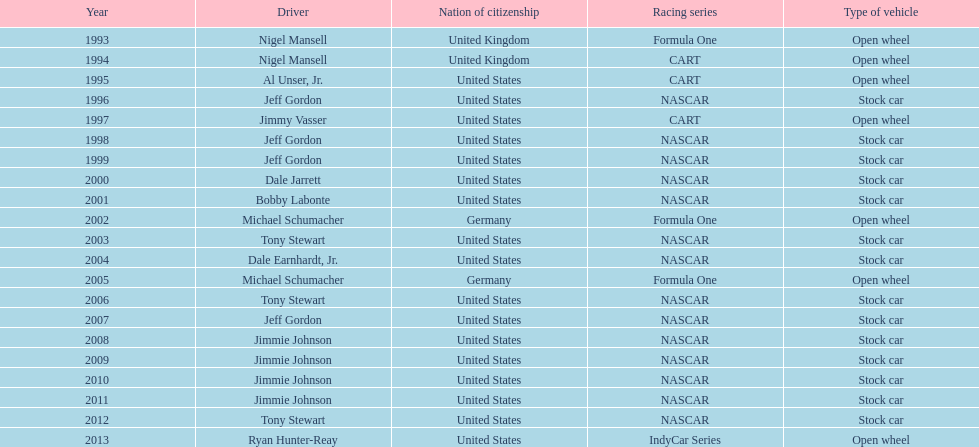In the group of nigel mansell, al unser jr., michael schumacher, and jeff gordon, only one of them has won only one espy award. who is that driver? Al Unser, Jr. Could you parse the entire table as a dict? {'header': ['Year', 'Driver', 'Nation of citizenship', 'Racing series', 'Type of vehicle'], 'rows': [['1993', 'Nigel Mansell', 'United Kingdom', 'Formula One', 'Open wheel'], ['1994', 'Nigel Mansell', 'United Kingdom', 'CART', 'Open wheel'], ['1995', 'Al Unser, Jr.', 'United States', 'CART', 'Open wheel'], ['1996', 'Jeff Gordon', 'United States', 'NASCAR', 'Stock car'], ['1997', 'Jimmy Vasser', 'United States', 'CART', 'Open wheel'], ['1998', 'Jeff Gordon', 'United States', 'NASCAR', 'Stock car'], ['1999', 'Jeff Gordon', 'United States', 'NASCAR', 'Stock car'], ['2000', 'Dale Jarrett', 'United States', 'NASCAR', 'Stock car'], ['2001', 'Bobby Labonte', 'United States', 'NASCAR', 'Stock car'], ['2002', 'Michael Schumacher', 'Germany', 'Formula One', 'Open wheel'], ['2003', 'Tony Stewart', 'United States', 'NASCAR', 'Stock car'], ['2004', 'Dale Earnhardt, Jr.', 'United States', 'NASCAR', 'Stock car'], ['2005', 'Michael Schumacher', 'Germany', 'Formula One', 'Open wheel'], ['2006', 'Tony Stewart', 'United States', 'NASCAR', 'Stock car'], ['2007', 'Jeff Gordon', 'United States', 'NASCAR', 'Stock car'], ['2008', 'Jimmie Johnson', 'United States', 'NASCAR', 'Stock car'], ['2009', 'Jimmie Johnson', 'United States', 'NASCAR', 'Stock car'], ['2010', 'Jimmie Johnson', 'United States', 'NASCAR', 'Stock car'], ['2011', 'Jimmie Johnson', 'United States', 'NASCAR', 'Stock car'], ['2012', 'Tony Stewart', 'United States', 'NASCAR', 'Stock car'], ['2013', 'Ryan Hunter-Reay', 'United States', 'IndyCar Series', 'Open wheel']]} 